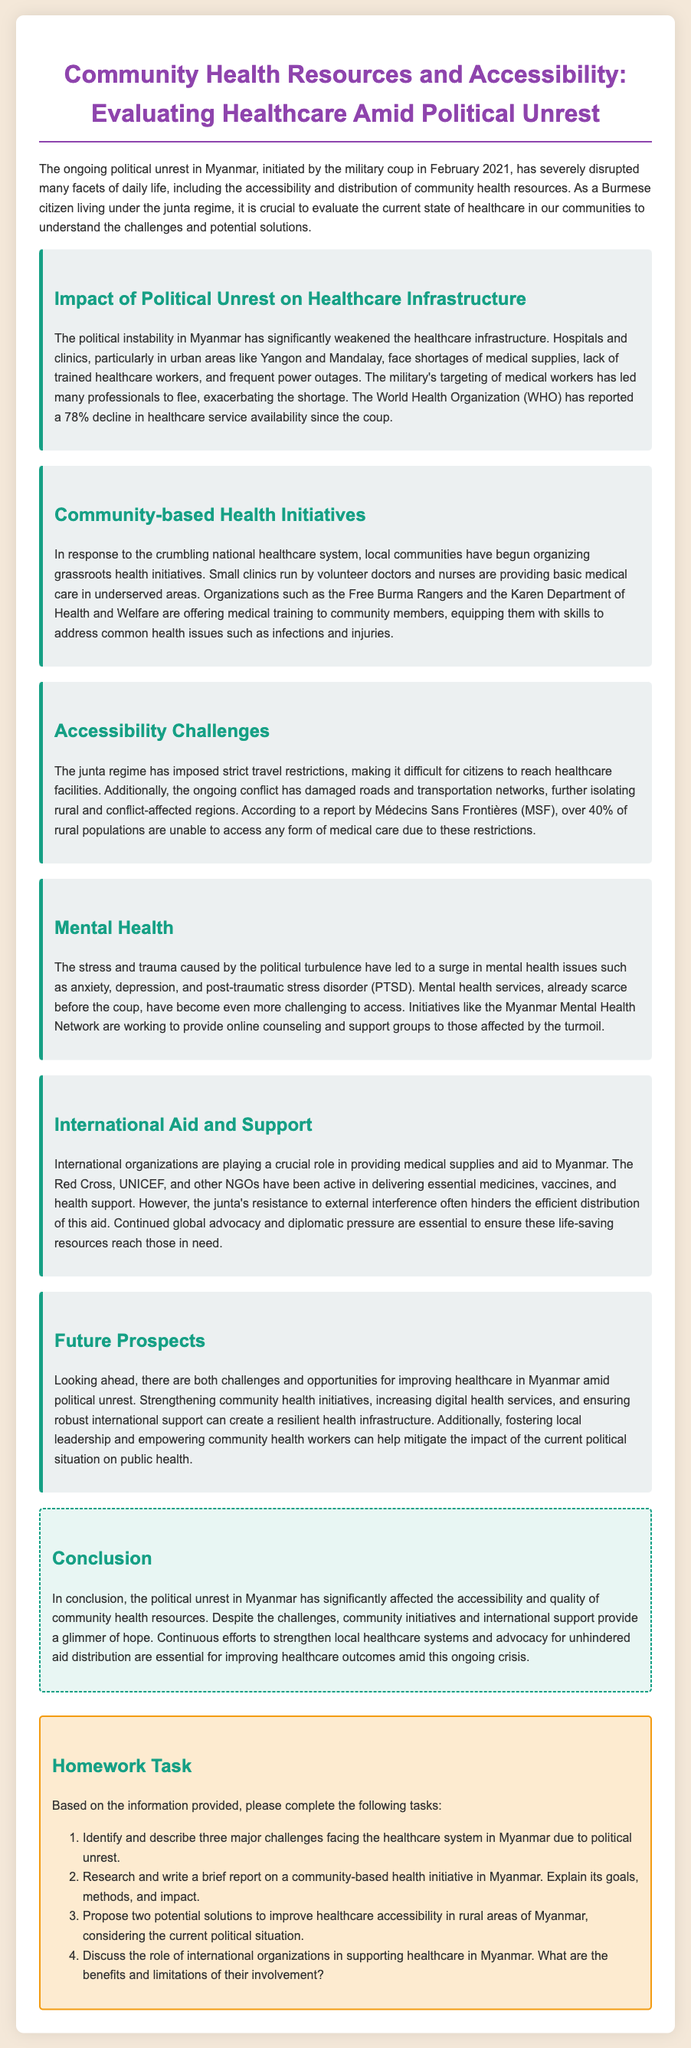What percentage decline in healthcare service availability did the WHO report? The WHO reported a 78% decline in healthcare service availability since the coup.
Answer: 78% Which organization offers medical training to community members? Organizations such as the Free Burma Rangers and the Karen Department of Health and Welfare are mentioned as offering medical training to community members.
Answer: Free Burma Rangers What is one major accessibility challenge mentioned in the document? The junta regime has imposed strict travel restrictions, making it difficult for citizens to reach healthcare facilities.
Answer: Travel restrictions What type of issues has there been a surge in due to political turbulence? The stress and trauma caused by political turbulence have led to a surge in mental health issues.
Answer: Mental health issues Which international organization has been active in delivering essential medicines to Myanmar? The Red Cross is mentioned as one of the international organizations actively delivering essential medicines and aid.
Answer: Red Cross What are two potential solutions proposed to improve healthcare accessibility in rural areas? Propose two potential solutions to improve healthcare accessibility in rural areas of Myanmar, considering the current political situation.
Answer: Solutions to improve healthcare accessibility What is the goal of the Myanmar Mental Health Network? The Myanmar Mental Health Network is working to provide online counseling and support groups to those affected by the turmoil.
Answer: Provide online counseling What has happened to many trained healthcare workers since the coup? The military's targeting of medical workers has led many professionals to flee, exacerbating the shortage.
Answer: Flee What are the two main themes of the Homework tasks? The Homework tasks ask about challenges in healthcare and community initiatives.
Answer: Challenges and initiatives 